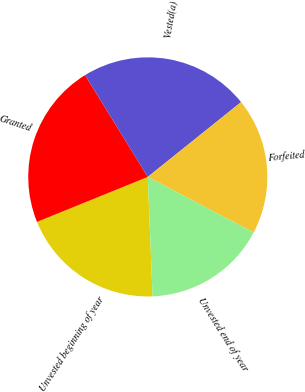<chart> <loc_0><loc_0><loc_500><loc_500><pie_chart><fcel>Unvested beginning of year<fcel>Granted<fcel>Vested(a)<fcel>Forfeited<fcel>Unvested end of year<nl><fcel>19.5%<fcel>22.35%<fcel>23.04%<fcel>18.45%<fcel>16.67%<nl></chart> 